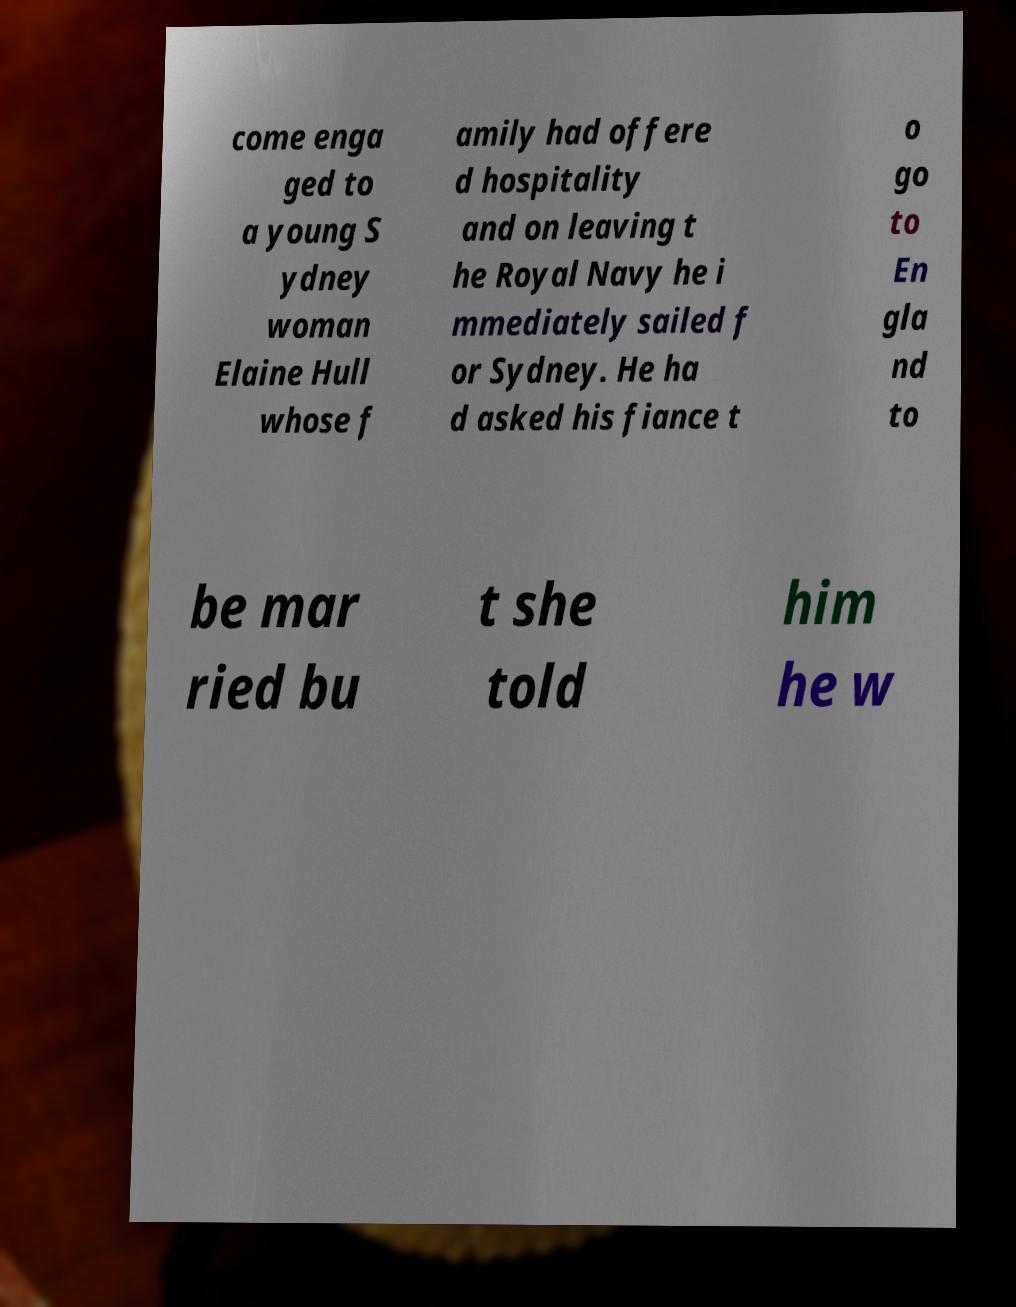Please read and relay the text visible in this image. What does it say? come enga ged to a young S ydney woman Elaine Hull whose f amily had offere d hospitality and on leaving t he Royal Navy he i mmediately sailed f or Sydney. He ha d asked his fiance t o go to En gla nd to be mar ried bu t she told him he w 